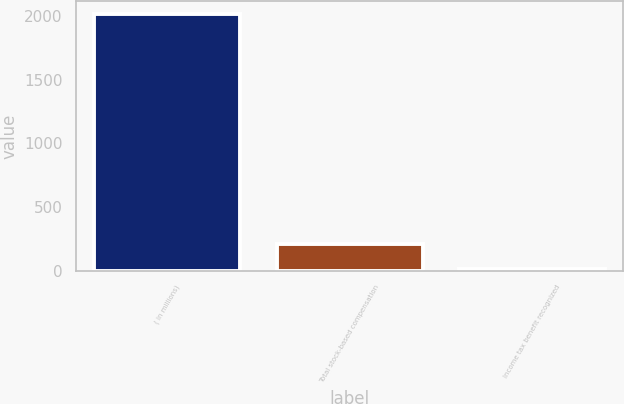<chart> <loc_0><loc_0><loc_500><loc_500><bar_chart><fcel>( in millions)<fcel>Total stock-based compensation<fcel>Income tax benefit recognized<nl><fcel>2016<fcel>214.2<fcel>14<nl></chart> 